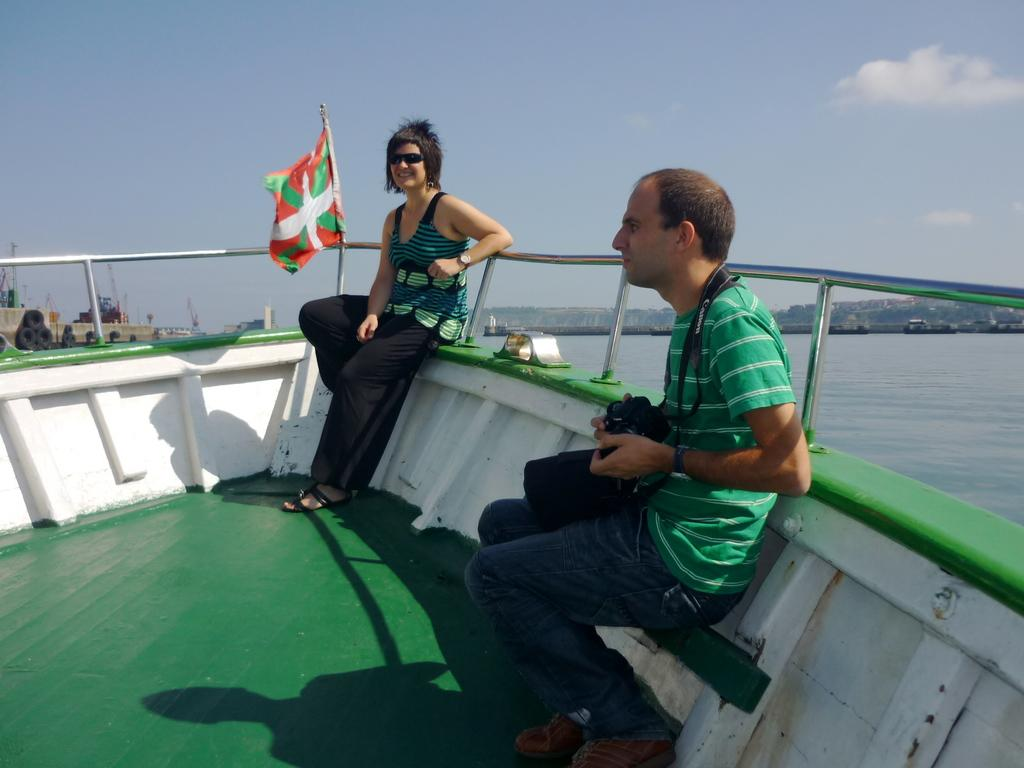Who is present in the image? There is a woman and a man in the image. What are they doing in the image? Both the woman and man are on a boat. What is the man holding in the image? The man is holding a camera. What is the woman wearing in the image? The woman has goggles. What can be seen in the background of the image? The sky is visible in the background of the image. What else is present in the image? There is water visible in the image, a flag, and other boats. Where is the throne located in the image? There is no throne present in the image. How many icicles are hanging from the boat in the image? There are no icicles present in the image; it is set on water, not ice. 